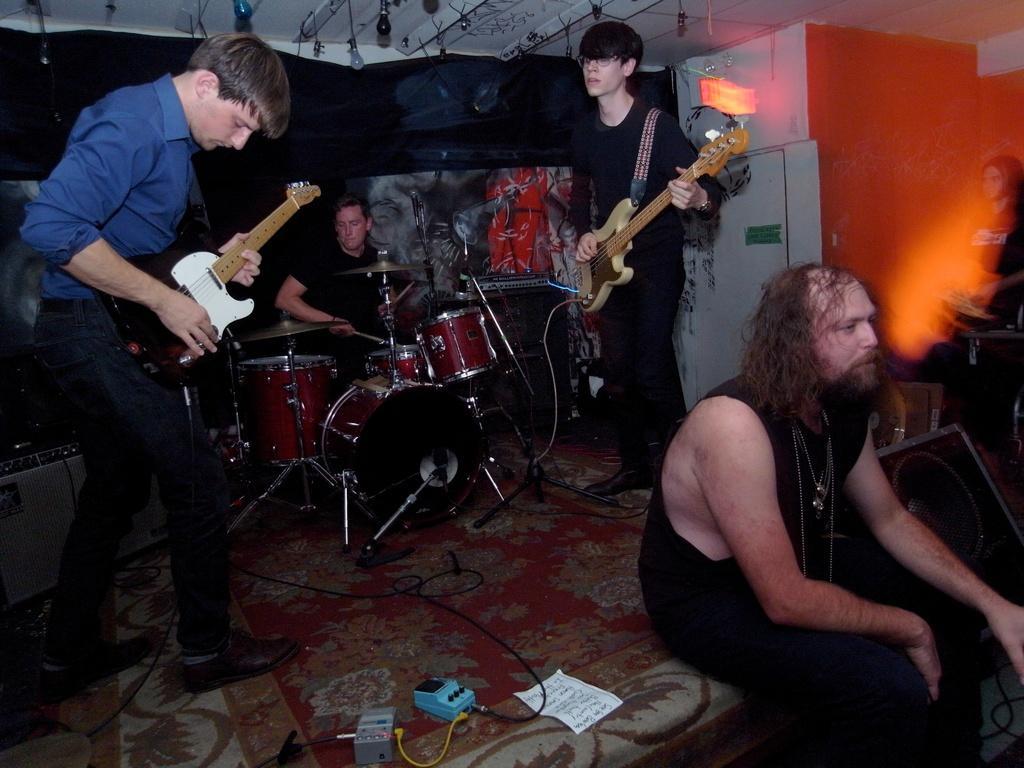Can you describe this image briefly? a person is sitting on the stage. behind him 2 people on the left and right are playing guitar. behind them a person is playing drums wearing black t shirt. at the back there is black background. at the right there is a orange wall. 